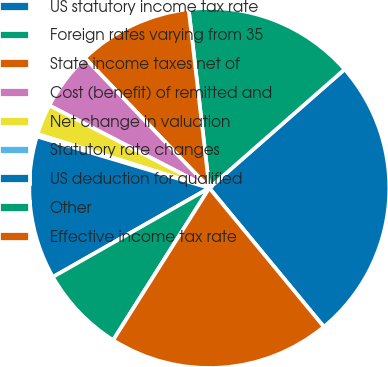Convert chart. <chart><loc_0><loc_0><loc_500><loc_500><pie_chart><fcel>US statutory income tax rate<fcel>Foreign rates varying from 35<fcel>State income taxes net of<fcel>Cost (benefit) of remitted and<fcel>Net change in valuation<fcel>Statutory rate changes<fcel>US deduction for qualified<fcel>Other<fcel>Effective income tax rate<nl><fcel>25.48%<fcel>15.37%<fcel>10.32%<fcel>5.27%<fcel>2.74%<fcel>0.22%<fcel>12.85%<fcel>7.8%<fcel>19.95%<nl></chart> 